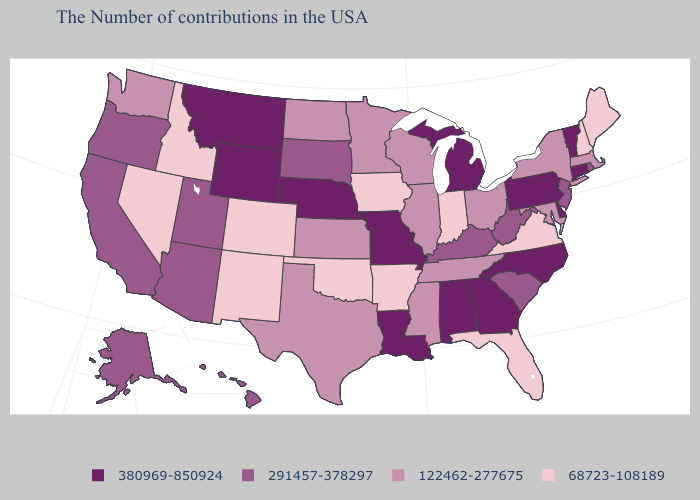Name the states that have a value in the range 122462-277675?
Answer briefly. Massachusetts, New York, Maryland, Ohio, Tennessee, Wisconsin, Illinois, Mississippi, Minnesota, Kansas, Texas, North Dakota, Washington. Name the states that have a value in the range 380969-850924?
Keep it brief. Vermont, Connecticut, Delaware, Pennsylvania, North Carolina, Georgia, Michigan, Alabama, Louisiana, Missouri, Nebraska, Wyoming, Montana. What is the highest value in the MidWest ?
Be succinct. 380969-850924. Name the states that have a value in the range 122462-277675?
Concise answer only. Massachusetts, New York, Maryland, Ohio, Tennessee, Wisconsin, Illinois, Mississippi, Minnesota, Kansas, Texas, North Dakota, Washington. Name the states that have a value in the range 122462-277675?
Concise answer only. Massachusetts, New York, Maryland, Ohio, Tennessee, Wisconsin, Illinois, Mississippi, Minnesota, Kansas, Texas, North Dakota, Washington. Which states have the lowest value in the USA?
Write a very short answer. Maine, New Hampshire, Virginia, Florida, Indiana, Arkansas, Iowa, Oklahoma, Colorado, New Mexico, Idaho, Nevada. Name the states that have a value in the range 68723-108189?
Short answer required. Maine, New Hampshire, Virginia, Florida, Indiana, Arkansas, Iowa, Oklahoma, Colorado, New Mexico, Idaho, Nevada. What is the highest value in the USA?
Short answer required. 380969-850924. What is the value of Louisiana?
Short answer required. 380969-850924. Does New Mexico have the lowest value in the West?
Quick response, please. Yes. What is the value of Colorado?
Write a very short answer. 68723-108189. Is the legend a continuous bar?
Write a very short answer. No. Which states hav the highest value in the MidWest?
Answer briefly. Michigan, Missouri, Nebraska. Name the states that have a value in the range 380969-850924?
Give a very brief answer. Vermont, Connecticut, Delaware, Pennsylvania, North Carolina, Georgia, Michigan, Alabama, Louisiana, Missouri, Nebraska, Wyoming, Montana. Among the states that border Georgia , which have the highest value?
Be succinct. North Carolina, Alabama. 